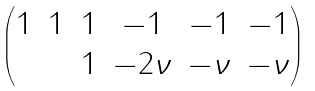<formula> <loc_0><loc_0><loc_500><loc_500>\begin{pmatrix} 1 & 1 & 1 & - 1 & - 1 & - 1 \\ & & 1 & - 2 \nu & - \nu & - \nu \end{pmatrix}</formula> 